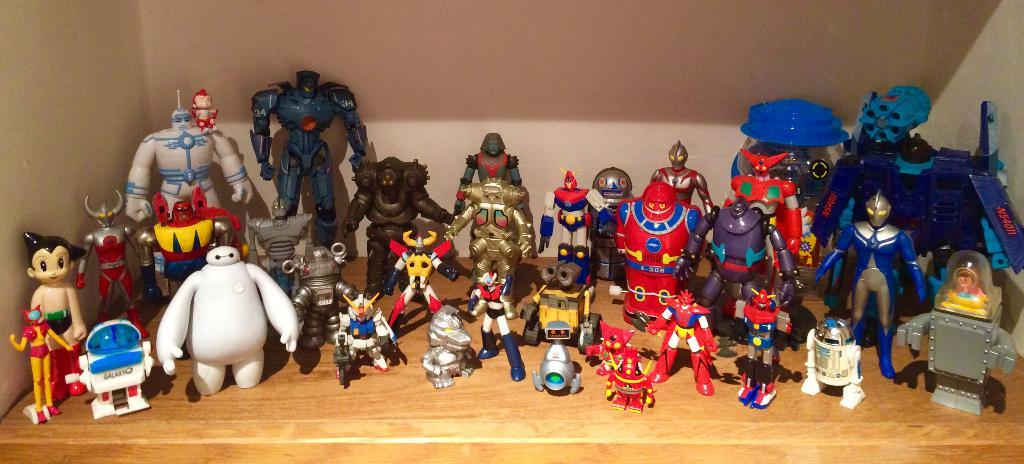What can be seen in the picture? There is a shelf in the picture. What is on the shelf? There are many toys present on the shelf. How many apples are on the shelf in the image? There is no mention of apples in the image; the shelf contains many toys. 